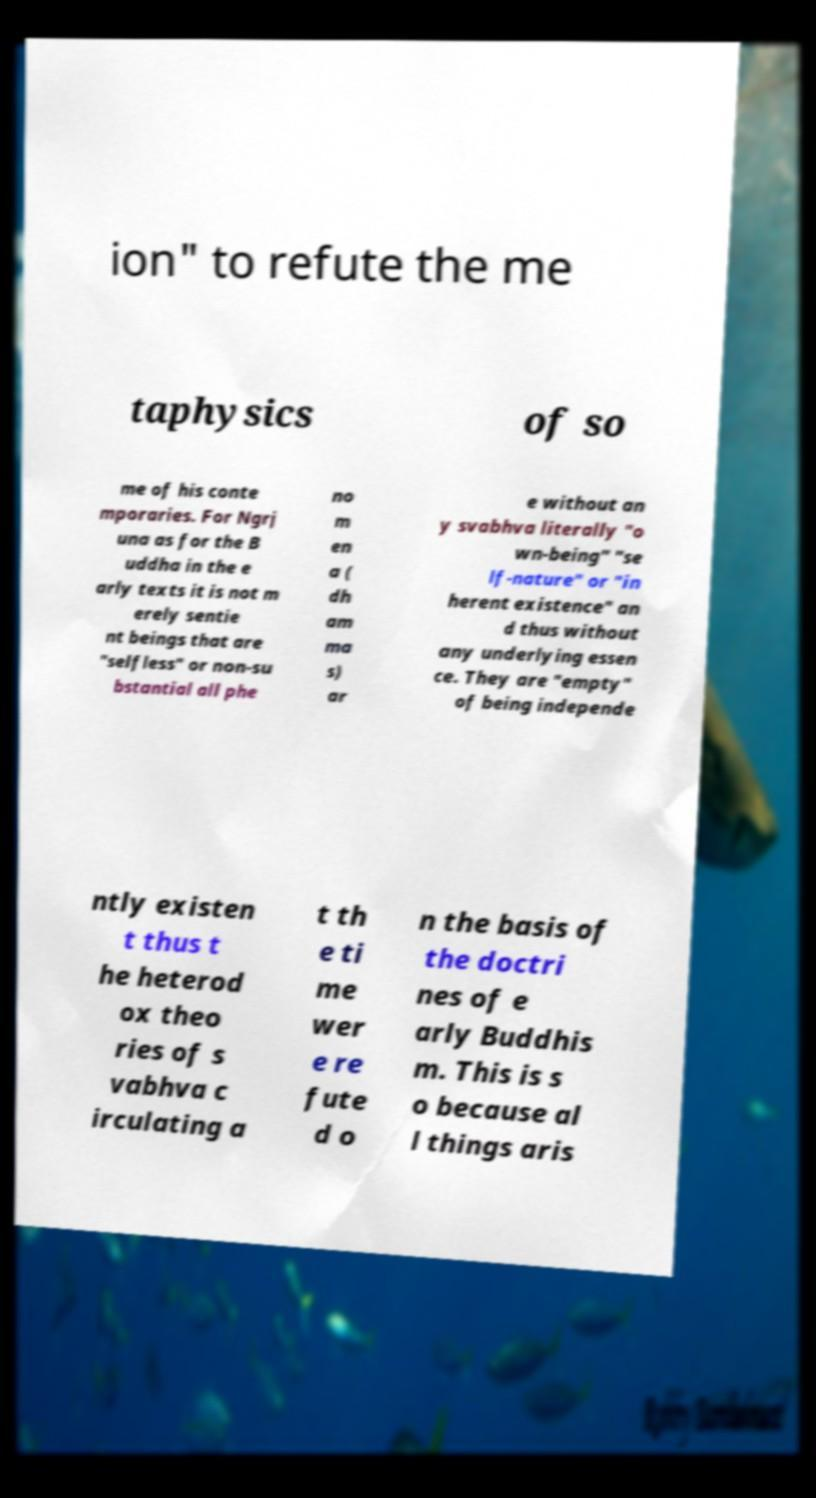I need the written content from this picture converted into text. Can you do that? ion" to refute the me taphysics of so me of his conte mporaries. For Ngrj una as for the B uddha in the e arly texts it is not m erely sentie nt beings that are "selfless" or non-su bstantial all phe no m en a ( dh am ma s) ar e without an y svabhva literally "o wn-being" "se lf-nature" or "in herent existence" an d thus without any underlying essen ce. They are "empty" of being independe ntly existen t thus t he heterod ox theo ries of s vabhva c irculating a t th e ti me wer e re fute d o n the basis of the doctri nes of e arly Buddhis m. This is s o because al l things aris 